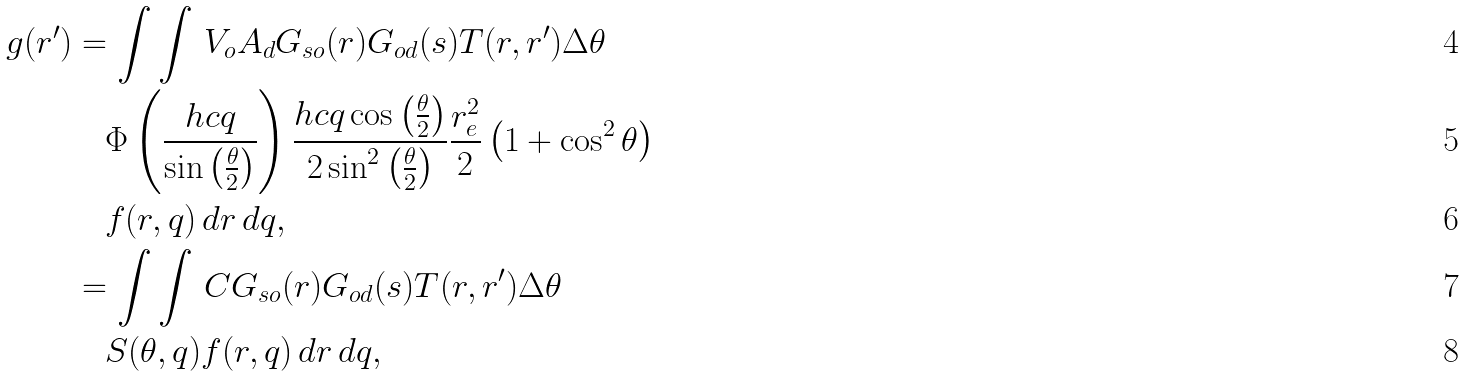Convert formula to latex. <formula><loc_0><loc_0><loc_500><loc_500>g ( r ^ { \prime } ) & = \int \int \, V _ { o } A _ { d } G _ { s o } ( r ) G _ { o d } ( s ) T ( r , r ^ { \prime } ) \Delta \theta \\ & \quad \Phi \left ( \frac { h c q } { \sin \left ( \frac { \theta } { 2 } \right ) } \right ) \frac { h c q \cos \left ( \frac { \theta } { 2 } \right ) } { 2 \sin ^ { 2 } \left ( \frac { \theta } { 2 } \right ) } \frac { r _ { e } ^ { 2 } } { 2 } \left ( 1 + \cos ^ { 2 } \theta \right ) \\ & \quad f ( r , q ) \, d r \, d q , \\ & = \int \int \, C G _ { s o } ( r ) G _ { o d } ( s ) T ( r , r ^ { \prime } ) \Delta \theta \\ & \quad S ( \theta , q ) f ( r , q ) \, d r \, d q ,</formula> 